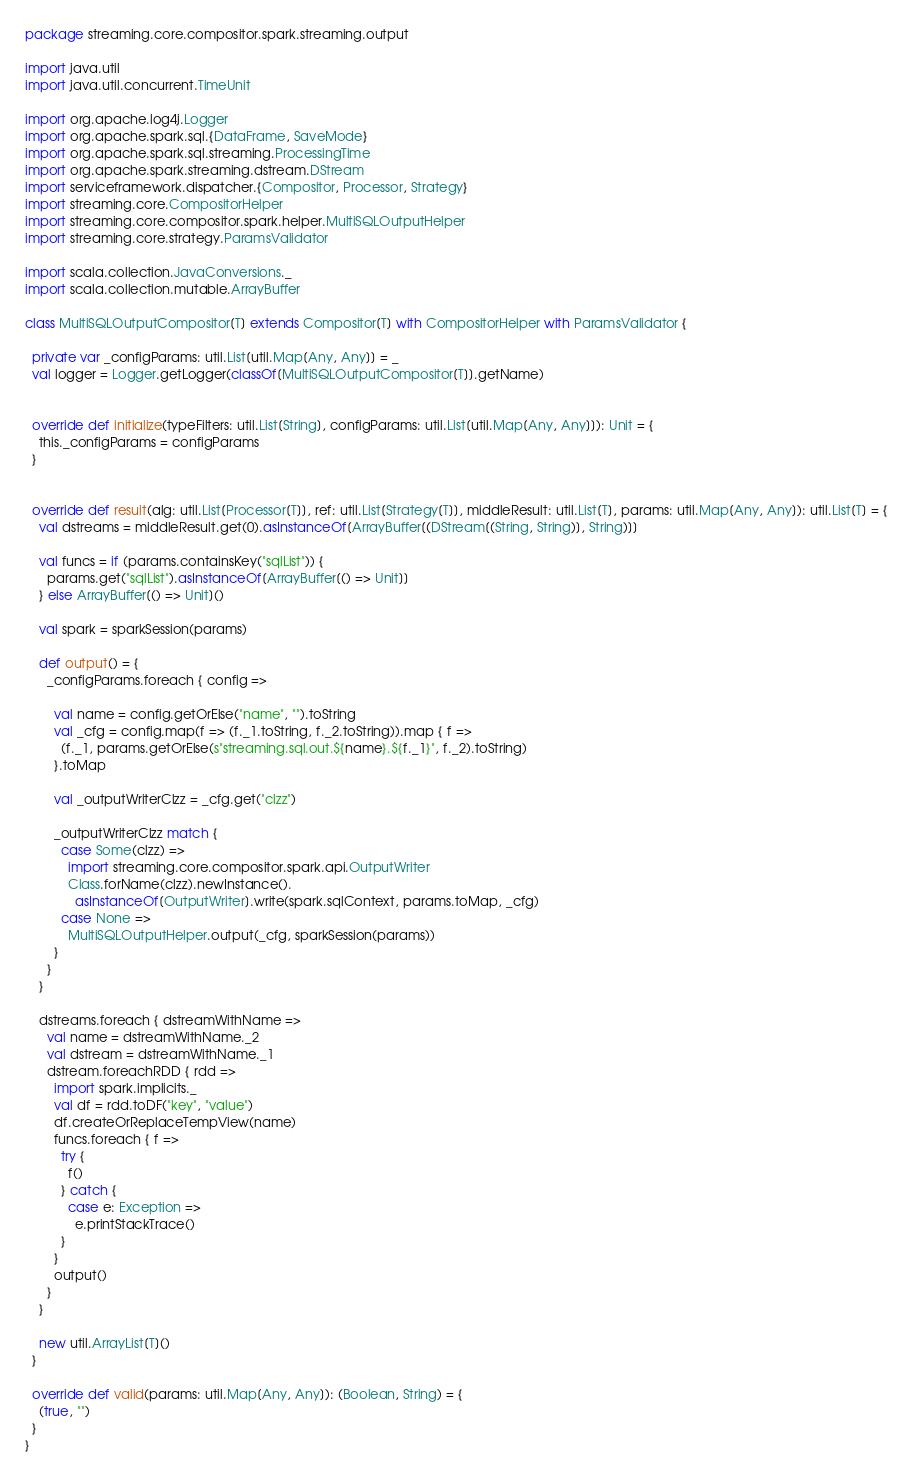<code> <loc_0><loc_0><loc_500><loc_500><_Scala_>package streaming.core.compositor.spark.streaming.output

import java.util
import java.util.concurrent.TimeUnit

import org.apache.log4j.Logger
import org.apache.spark.sql.{DataFrame, SaveMode}
import org.apache.spark.sql.streaming.ProcessingTime
import org.apache.spark.streaming.dstream.DStream
import serviceframework.dispatcher.{Compositor, Processor, Strategy}
import streaming.core.CompositorHelper
import streaming.core.compositor.spark.helper.MultiSQLOutputHelper
import streaming.core.strategy.ParamsValidator

import scala.collection.JavaConversions._
import scala.collection.mutable.ArrayBuffer

class MultiSQLOutputCompositor[T] extends Compositor[T] with CompositorHelper with ParamsValidator {

  private var _configParams: util.List[util.Map[Any, Any]] = _
  val logger = Logger.getLogger(classOf[MultiSQLOutputCompositor[T]].getName)


  override def initialize(typeFilters: util.List[String], configParams: util.List[util.Map[Any, Any]]): Unit = {
    this._configParams = configParams
  }


  override def result(alg: util.List[Processor[T]], ref: util.List[Strategy[T]], middleResult: util.List[T], params: util.Map[Any, Any]): util.List[T] = {
    val dstreams = middleResult.get(0).asInstanceOf[ArrayBuffer[(DStream[(String, String)], String)]]

    val funcs = if (params.containsKey("sqlList")) {
      params.get("sqlList").asInstanceOf[ArrayBuffer[() => Unit]]
    } else ArrayBuffer[() => Unit]()

    val spark = sparkSession(params)

    def output() = {
      _configParams.foreach { config =>

        val name = config.getOrElse("name", "").toString
        val _cfg = config.map(f => (f._1.toString, f._2.toString)).map { f =>
          (f._1, params.getOrElse(s"streaming.sql.out.${name}.${f._1}", f._2).toString)
        }.toMap

        val _outputWriterClzz = _cfg.get("clzz")

        _outputWriterClzz match {
          case Some(clzz) =>
            import streaming.core.compositor.spark.api.OutputWriter
            Class.forName(clzz).newInstance().
              asInstanceOf[OutputWriter].write(spark.sqlContext, params.toMap, _cfg)
          case None =>
            MultiSQLOutputHelper.output(_cfg, sparkSession(params))
        }
      }
    }

    dstreams.foreach { dstreamWithName =>
      val name = dstreamWithName._2
      val dstream = dstreamWithName._1
      dstream.foreachRDD { rdd =>
        import spark.implicits._
        val df = rdd.toDF("key", "value")
        df.createOrReplaceTempView(name)
        funcs.foreach { f =>
          try {
            f()
          } catch {
            case e: Exception =>
              e.printStackTrace()
          }
        }
        output()
      }
    }

    new util.ArrayList[T]()
  }

  override def valid(params: util.Map[Any, Any]): (Boolean, String) = {
    (true, "")
  }
}
</code> 